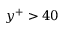Convert formula to latex. <formula><loc_0><loc_0><loc_500><loc_500>y ^ { + } > 4 0</formula> 